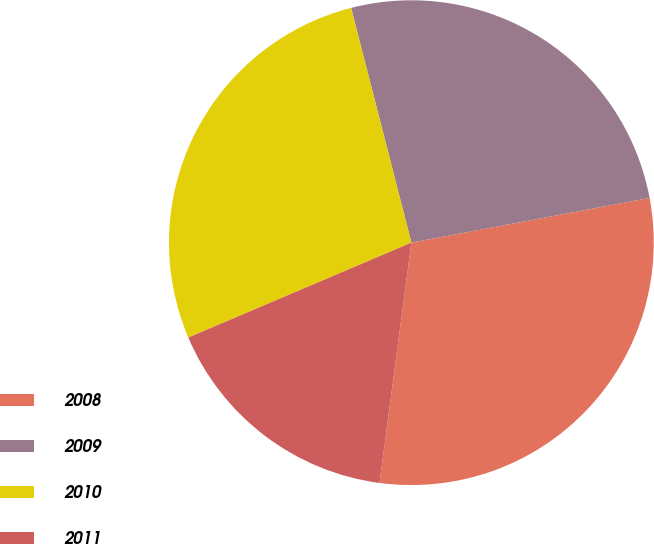Convert chart. <chart><loc_0><loc_0><loc_500><loc_500><pie_chart><fcel>2008<fcel>2009<fcel>2010<fcel>2011<nl><fcel>30.05%<fcel>26.04%<fcel>27.4%<fcel>16.5%<nl></chart> 